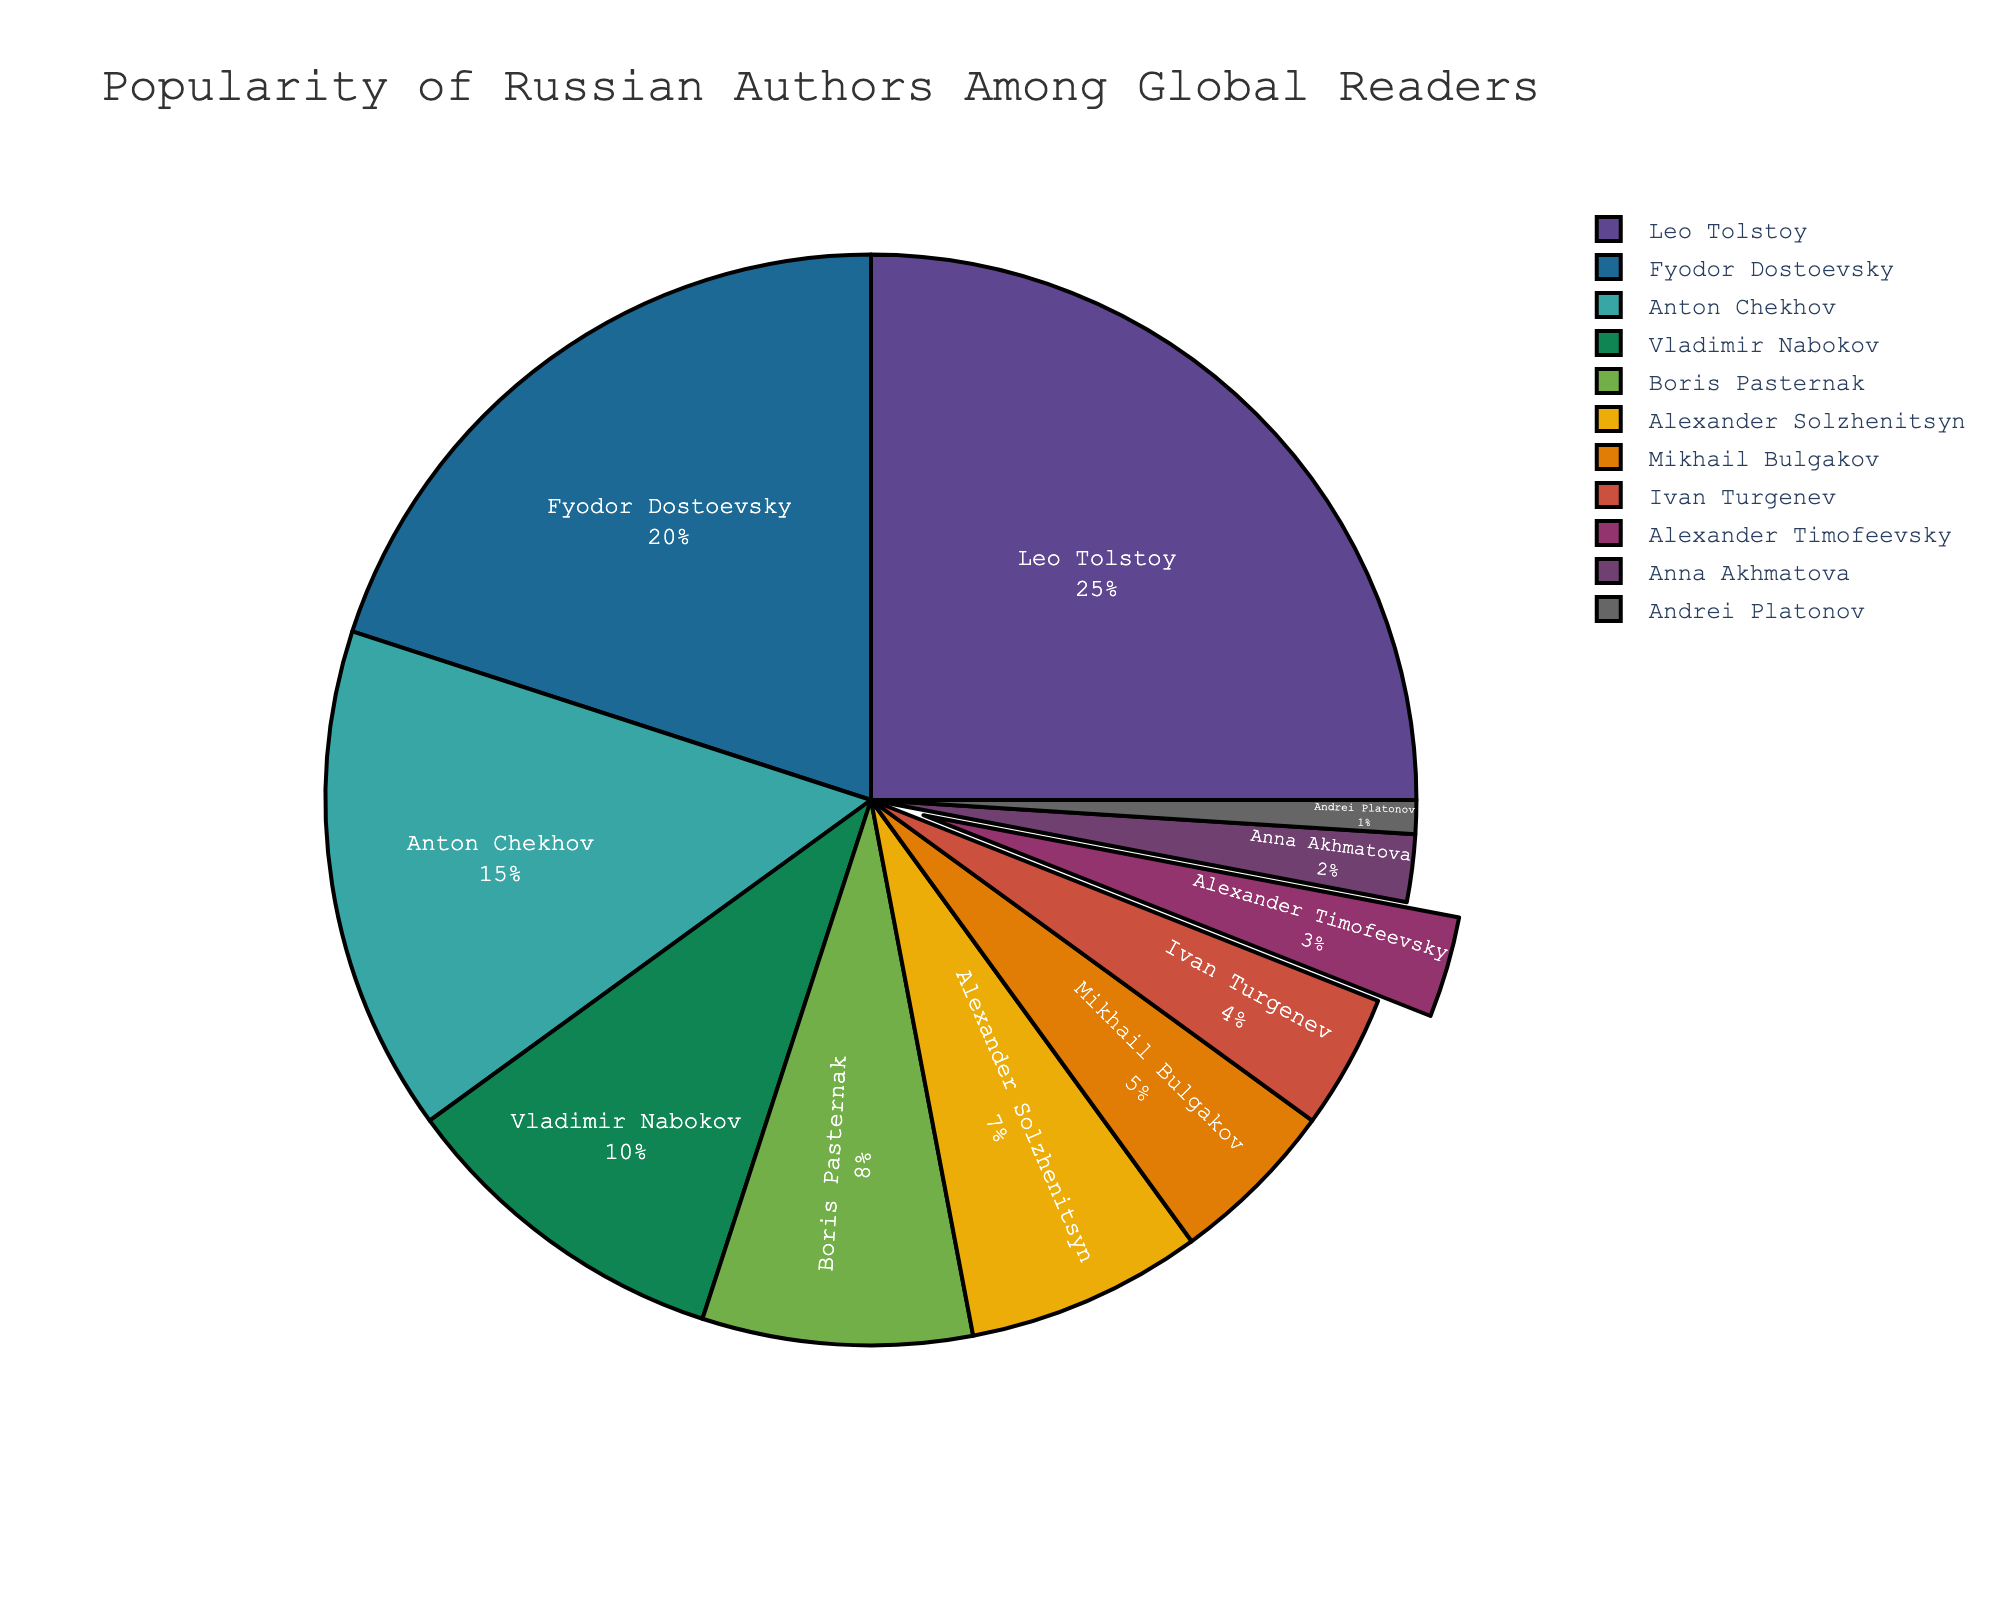Which author has the highest percentage of popularity among global readers? The figure shows the pie chart with each author's percentage of popularity. The author with the largest segment is Leo Tolstoy.
Answer: Leo Tolstoy How does the popularity of Alexander Timofeevsky compare to that of Boris Pasternak? Alexander Timofeevsky has 3% popularity, while Boris Pasternak has 8%. Comparing the two, we see that Boris Pasternak has a higher percentage.
Answer: Boris Pasternak is more popular What is the total percentage of popularity for authors with more than 10% popularity? The figure shows four authors with more than 10% popularity: Leo Tolstoy (25%), Fyodor Dostoevsky (20%), Anton Chekhov (15%), and Vladimir Nabokov (10%). Summing these values: 25 + 20 + 15 + 10 = 70%.
Answer: 70% By how much does the popularity percentage of Anton Chekhov exceed that of Alexander Solzhenitsyn? The figure indicates Anton Chekhov has a popularity of 15%, and Alexander Solzhenitsyn has 7%. Subtracting these values: 15 - 7 = 8%.
Answer: 8% What is the combined percentage of popularity for female authors in the chart? The female authors are Anna Akhmatova (2%). No others listed are female. Summing their percentages: 2%.
Answer: 2% Which author has their slice "pulled" out and why might that be? The slice for Alexander Timofeevsky is visually pulled out. This could be to highlight his presence due to the author's specific interests.
Answer: Alexander Timofeevsky What is the ratio of the popularity of Fyodor Dostoevsky to Leo Tolstoy? The figure shows Fyodor Dostoevsky has a popularity of 20% and Leo Tolstoy 25%. The ratio is 20:25, which simplifies to 4:5.
Answer: 4:5 Identify an author with less than a 5% popularity and describe their contribution to Russian literature. One such author is Ivan Turgenev with 4% popularity. Turgenev is known for his novels "Fathers and Sons" and "A Month in the Country".
Answer: Ivan Turgenev What is the average percentage of the top five most popular authors? The top five most popular authors are Leo Tolstoy (25%), Fyodor Dostoevsky (20%), Anton Chekhov (15%), Vladimir Nabokov (10%), and Boris Pasternak (8%). Adding these values: 25 + 20 + 15 + 10 + 8 = 78. Dividing by 5, the average is 78 / 5 = 15.6%.
Answer: 15.6% 